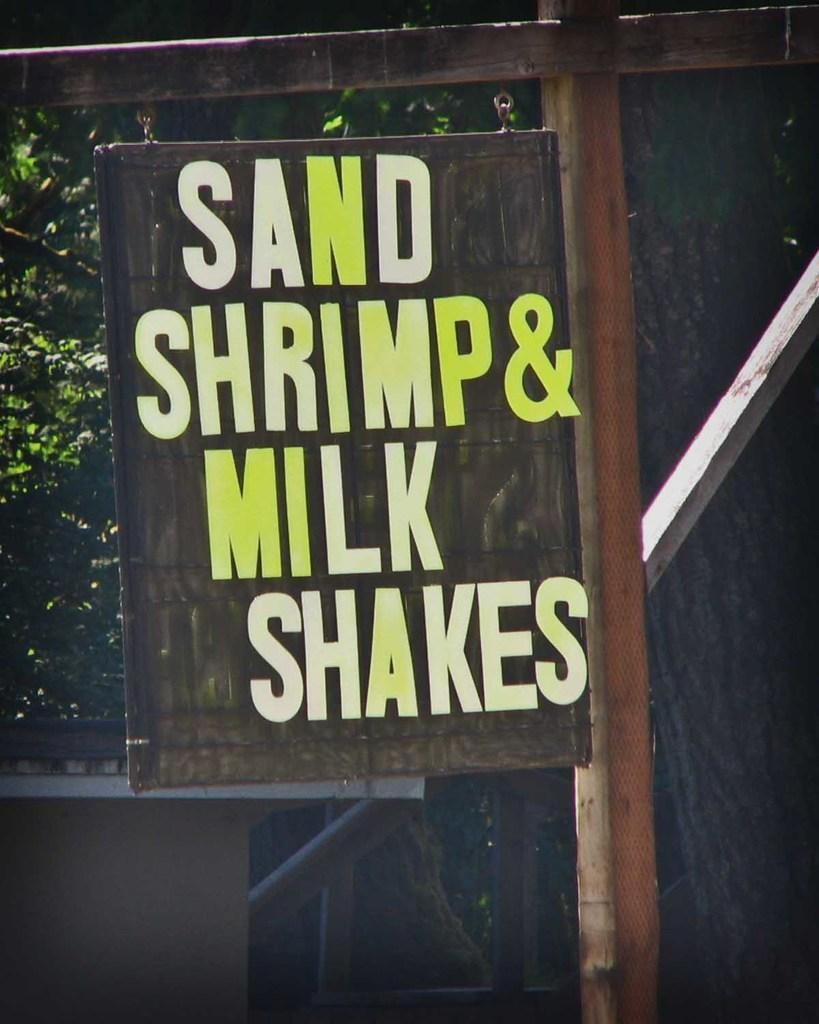In one or two sentences, can you explain what this image depicts? In this image we can see some text on the board. We can see the trunk of the tree at the right side of the image. 